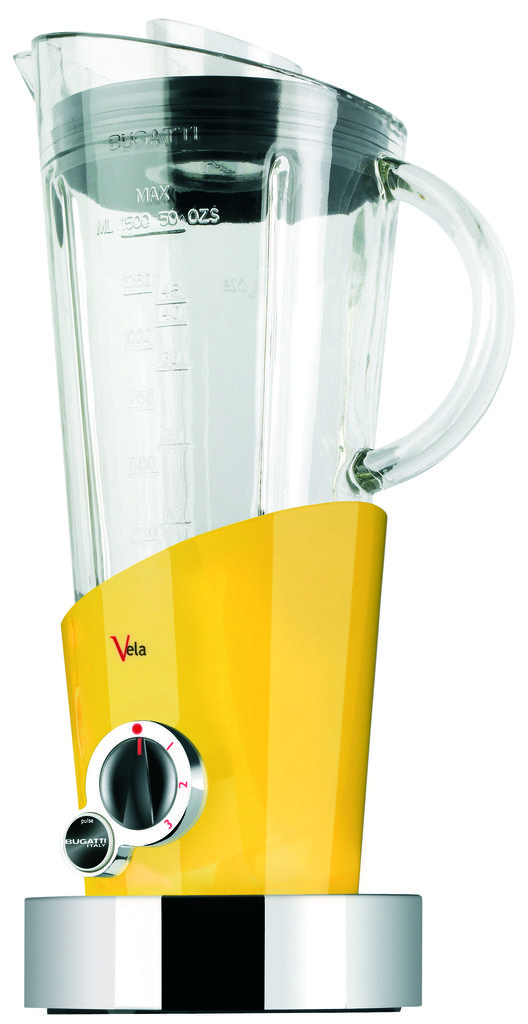How many ounces can this glass pitcher contain?
Your answer should be compact. 50. 